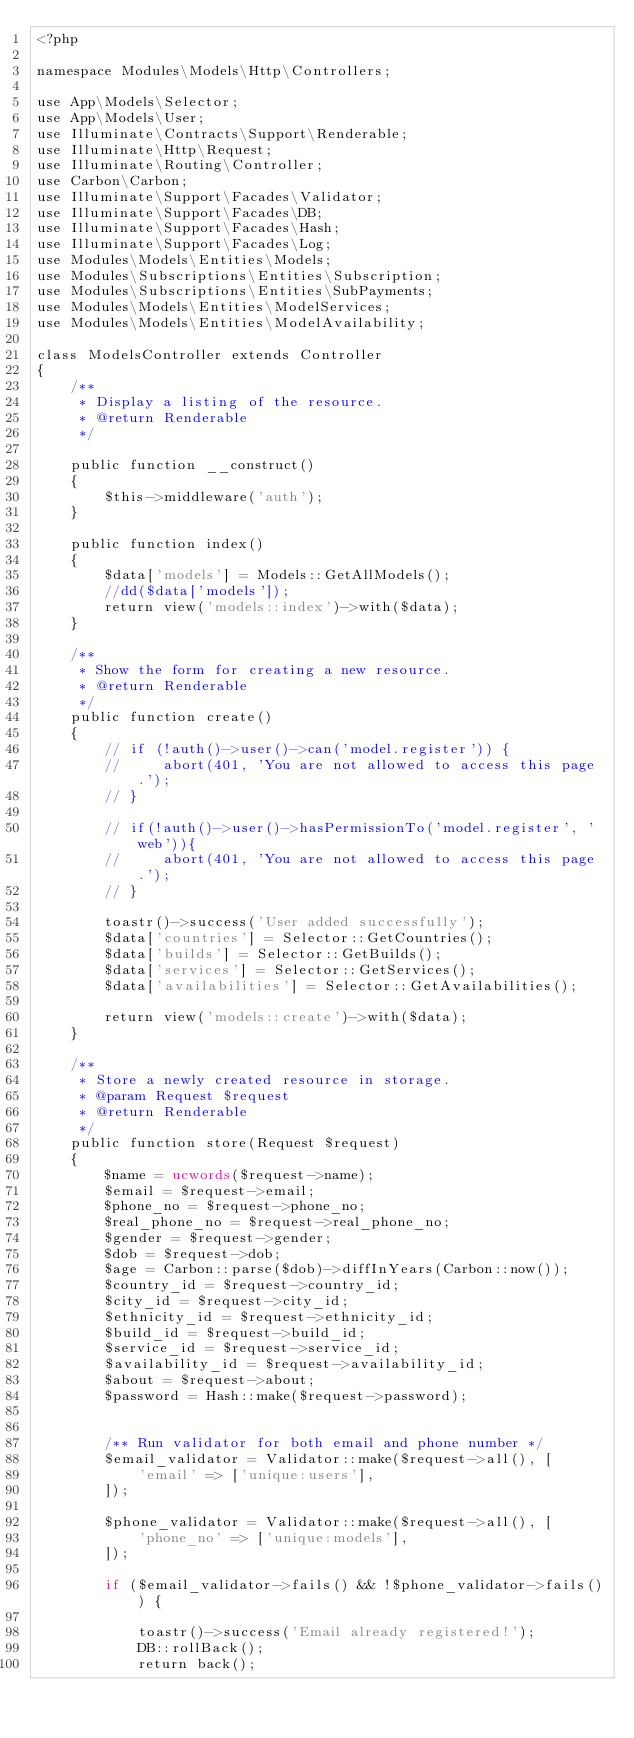Convert code to text. <code><loc_0><loc_0><loc_500><loc_500><_PHP_><?php

namespace Modules\Models\Http\Controllers;

use App\Models\Selector;
use App\Models\User;
use Illuminate\Contracts\Support\Renderable;
use Illuminate\Http\Request;
use Illuminate\Routing\Controller;
use Carbon\Carbon;
use Illuminate\Support\Facades\Validator;
use Illuminate\Support\Facades\DB;
use Illuminate\Support\Facades\Hash;
use Illuminate\Support\Facades\Log;
use Modules\Models\Entities\Models;
use Modules\Subscriptions\Entities\Subscription;
use Modules\Subscriptions\Entities\SubPayments;
use Modules\Models\Entities\ModelServices;
use Modules\Models\Entities\ModelAvailability;

class ModelsController extends Controller
{
    /**
     * Display a listing of the resource.
     * @return Renderable
     */

    public function __construct()
    {
        $this->middleware('auth');
    }

    public function index()
    {
        $data['models'] = Models::GetAllModels();
        //dd($data['models']);
        return view('models::index')->with($data);
    }

    /**
     * Show the form for creating a new resource.
     * @return Renderable
     */
    public function create()
    {
        // if (!auth()->user()->can('model.register')) {
        //     abort(401, 'You are not allowed to access this page.');
        // }

        // if(!auth()->user()->hasPermissionTo('model.register', 'web')){
        //     abort(401, 'You are not allowed to access this page.');
        // }

        toastr()->success('User added successfully');
        $data['countries'] = Selector::GetCountries();
        $data['builds'] = Selector::GetBuilds();
        $data['services'] = Selector::GetServices();
        $data['availabilities'] = Selector::GetAvailabilities();

        return view('models::create')->with($data);
    }

    /**
     * Store a newly created resource in storage.
     * @param Request $request
     * @return Renderable
     */
    public function store(Request $request)
    {
        $name = ucwords($request->name);
        $email = $request->email;
        $phone_no = $request->phone_no;
        $real_phone_no = $request->real_phone_no;
        $gender = $request->gender;
        $dob = $request->dob;
        $age = Carbon::parse($dob)->diffInYears(Carbon::now());
        $country_id = $request->country_id;
        $city_id = $request->city_id;
        $ethnicity_id = $request->ethnicity_id;
        $build_id = $request->build_id;
        $service_id = $request->service_id;
        $availability_id = $request->availability_id;
        $about = $request->about;
        $password = Hash::make($request->password);


        /** Run validator for both email and phone number */
        $email_validator = Validator::make($request->all(), [
            'email' => ['unique:users'],
        ]);

        $phone_validator = Validator::make($request->all(), [
            'phone_no' => ['unique:models'],
        ]);

        if ($email_validator->fails() && !$phone_validator->fails()) {

            toastr()->success('Email already registered!');
            DB::rollBack();
            return back();</code> 